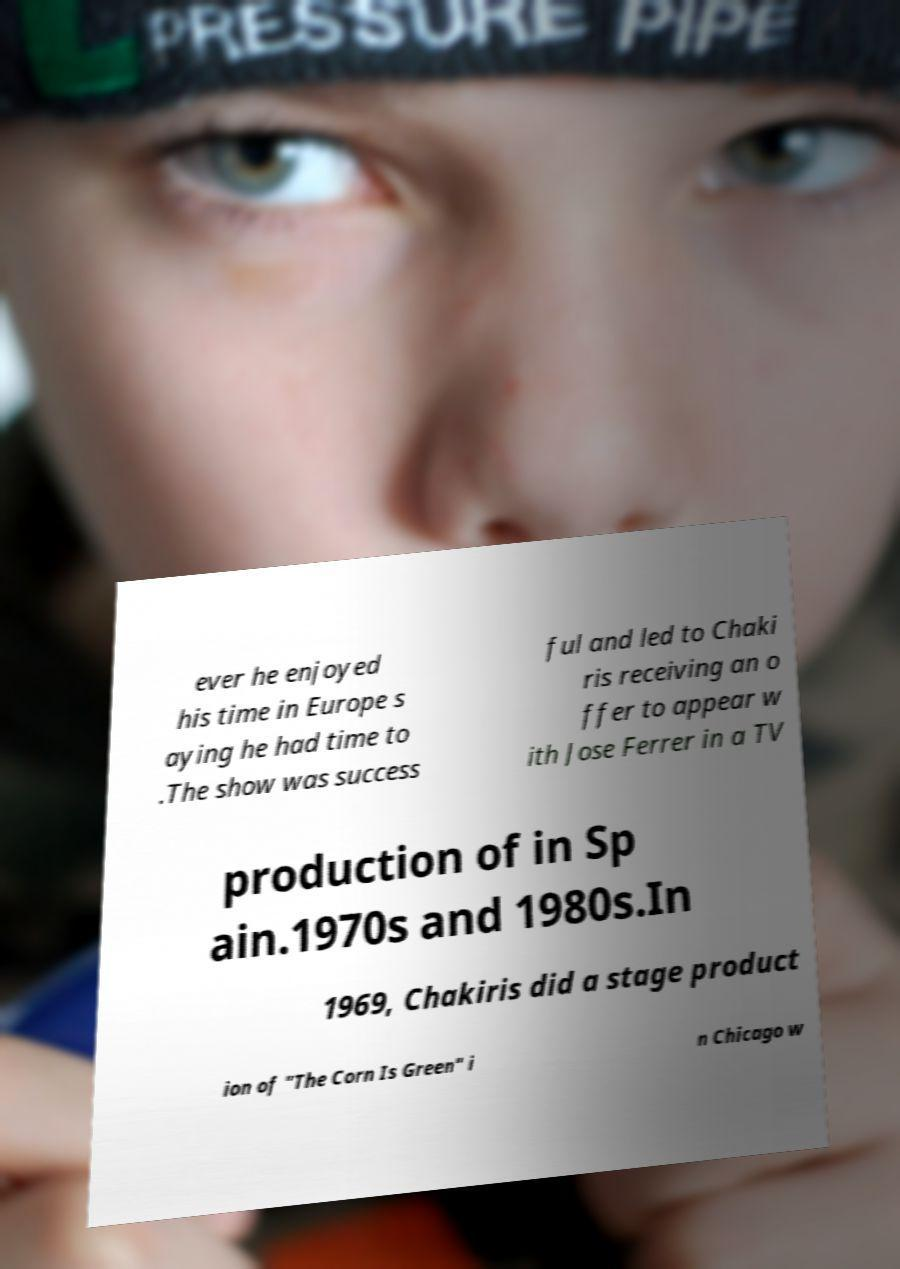Can you read and provide the text displayed in the image?This photo seems to have some interesting text. Can you extract and type it out for me? ever he enjoyed his time in Europe s aying he had time to .The show was success ful and led to Chaki ris receiving an o ffer to appear w ith Jose Ferrer in a TV production of in Sp ain.1970s and 1980s.In 1969, Chakiris did a stage product ion of "The Corn Is Green" i n Chicago w 